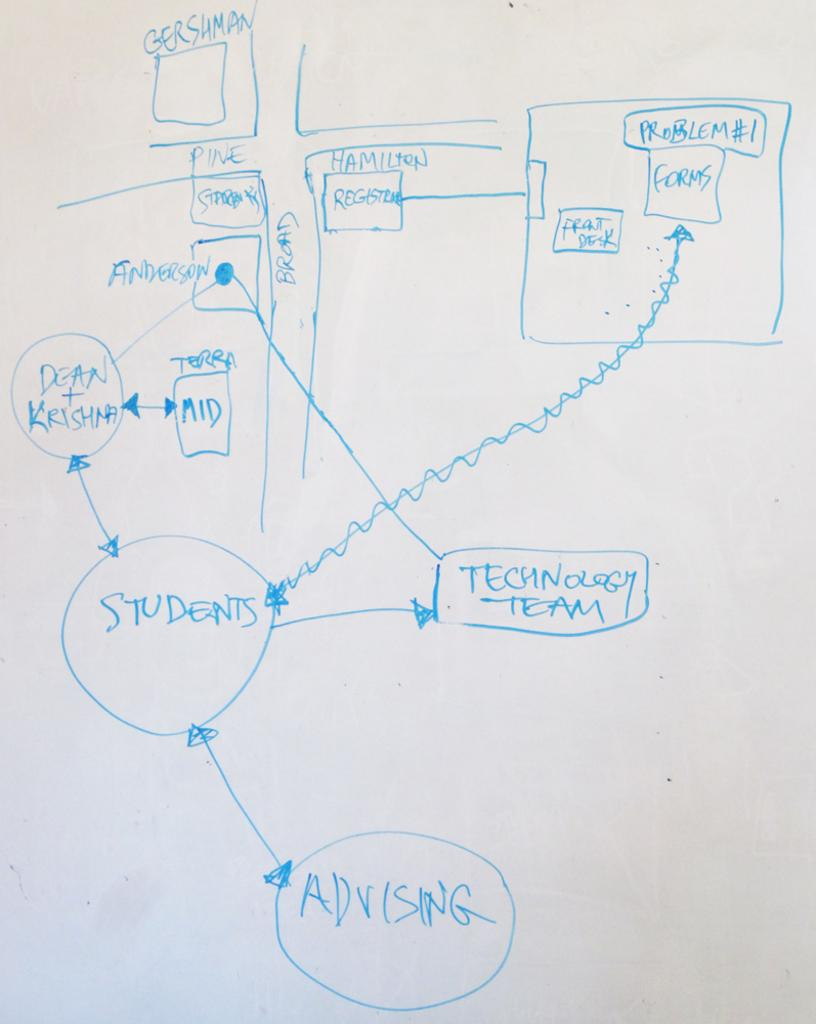<image>
Relay a brief, clear account of the picture shown. A whiteboard shows a rough map for the flow of Advising, Students, Technology Team, and more. 